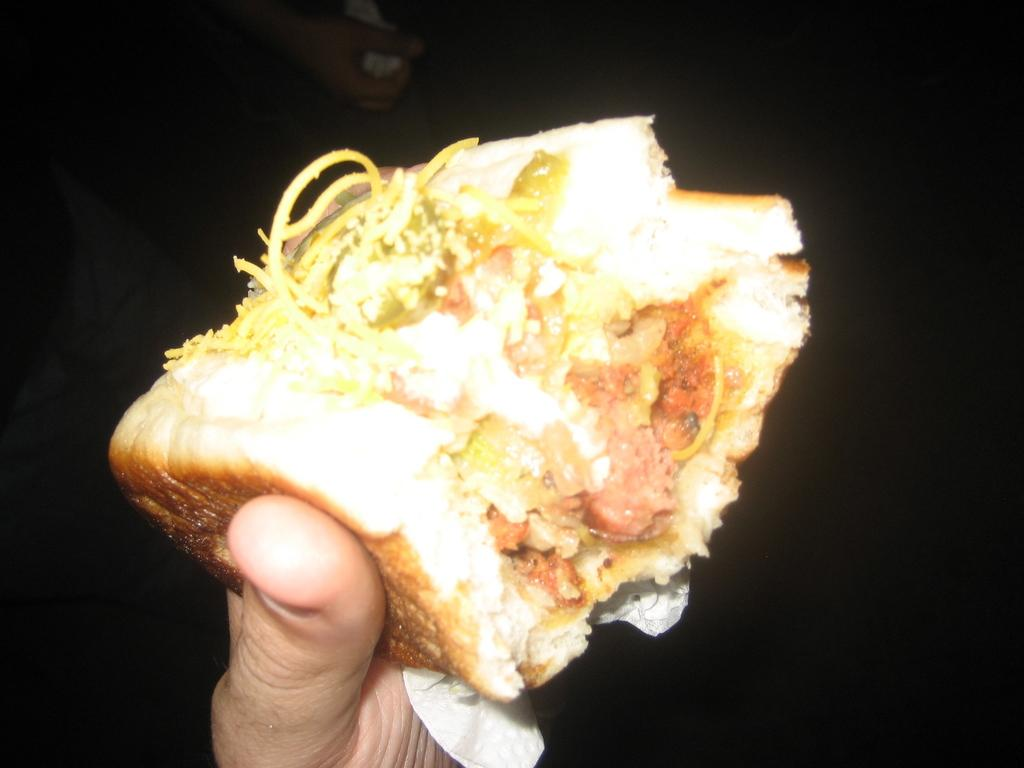What is the person's hand holding in the image? The person's hand is holding a food item in the image. What can be observed about the lighting in the image? The background of the image is dark. What type of grain is being used in the war depicted in the image? There is no war or grain present in the image; it only shows a person's hand holding a food item with a dark background. 